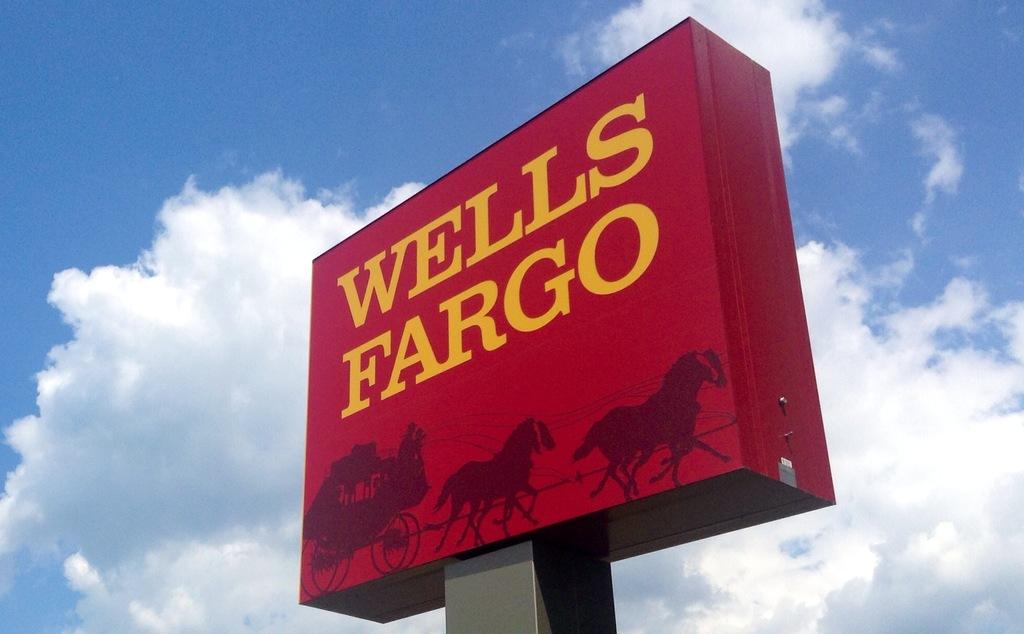What is the sign?
Your answer should be very brief. Wells fargo. 